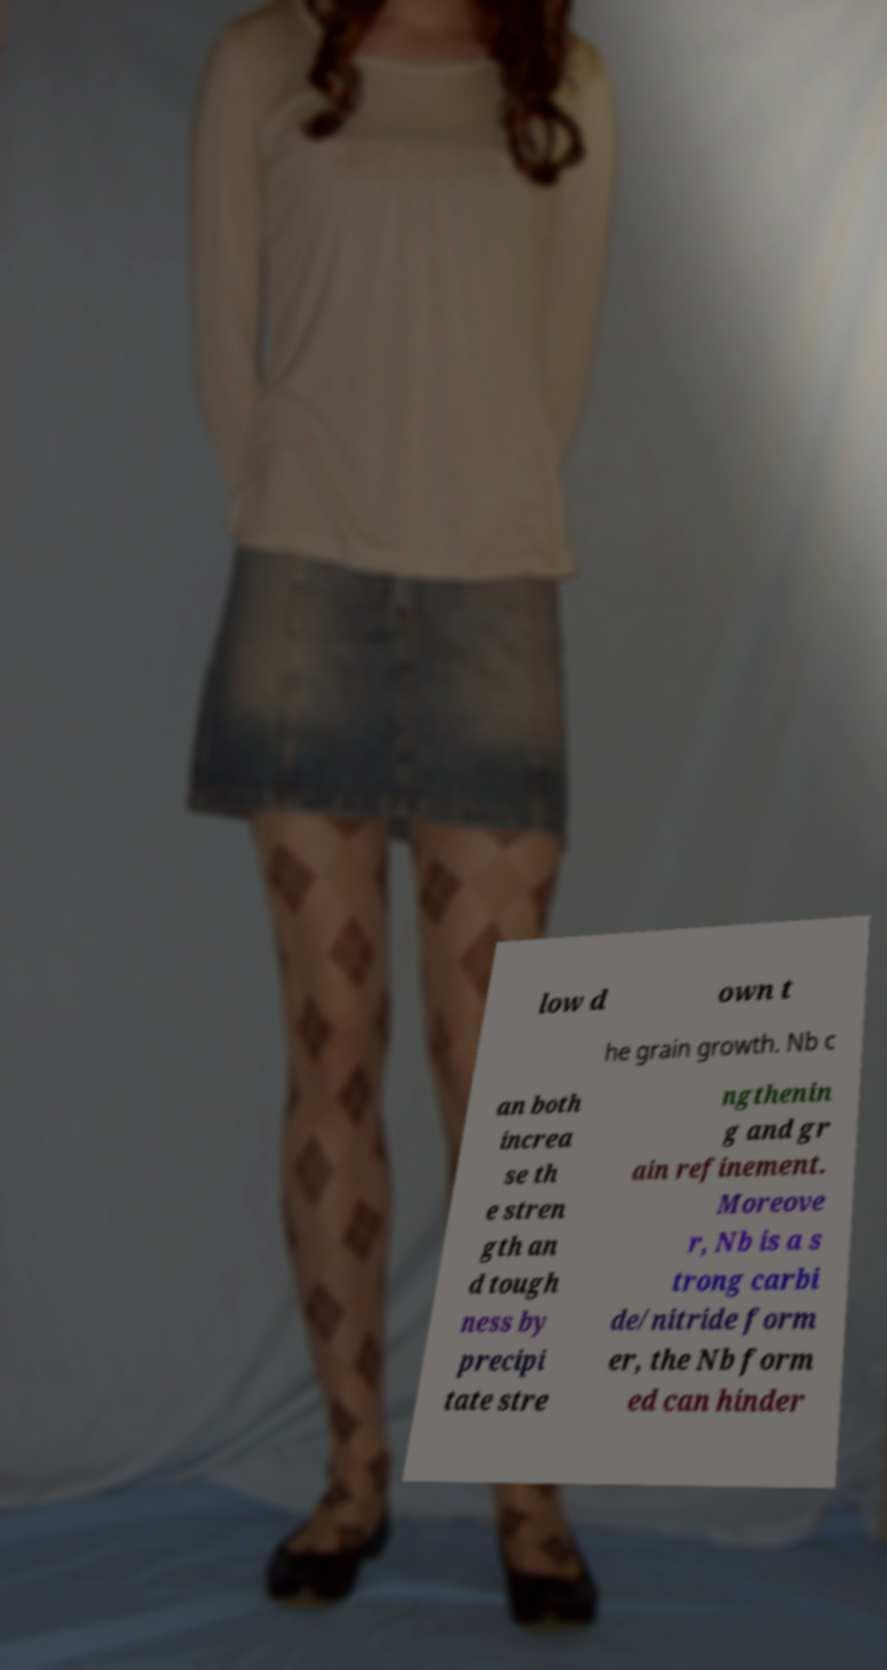I need the written content from this picture converted into text. Can you do that? low d own t he grain growth. Nb c an both increa se th e stren gth an d tough ness by precipi tate stre ngthenin g and gr ain refinement. Moreove r, Nb is a s trong carbi de/nitride form er, the Nb form ed can hinder 